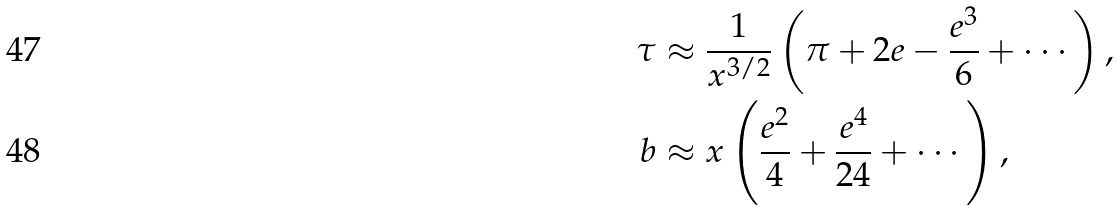<formula> <loc_0><loc_0><loc_500><loc_500>\tau & \approx \frac { 1 } { x ^ { 3 / 2 } } \left ( \pi + 2 e - \frac { e ^ { 3 } } { 6 } + \cdots \right ) , \\ b & \approx x \left ( \frac { e ^ { 2 } } { 4 } + \frac { e ^ { 4 } } { 2 4 } + \cdots \right ) ,</formula> 